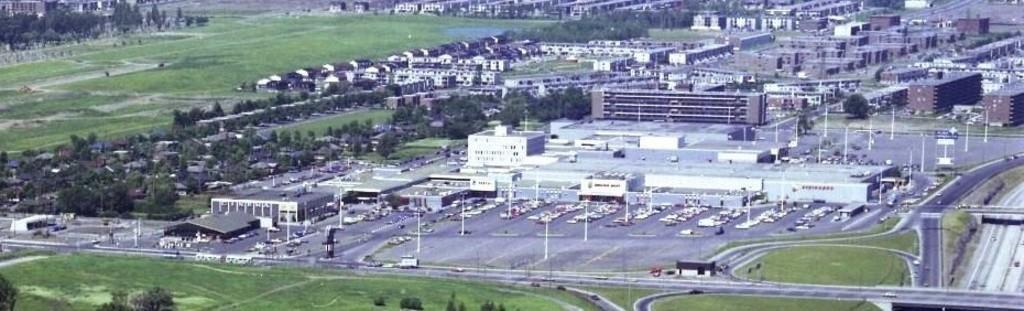In one or two sentences, can you explain what this image depicts? In this image we can see the many buildings, windows. And we can see the grass and surrounding trees. And we can see the road. And we can see the poles and lights. 